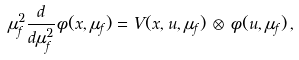Convert formula to latex. <formula><loc_0><loc_0><loc_500><loc_500>\mu _ { f } ^ { 2 } \frac { d } { d \mu _ { f } ^ { 2 } } \phi ( x , \mu _ { f } ) = V ( x , u , \mu _ { f } ) \, \otimes \, \phi ( u , \mu _ { f } ) \, ,</formula> 